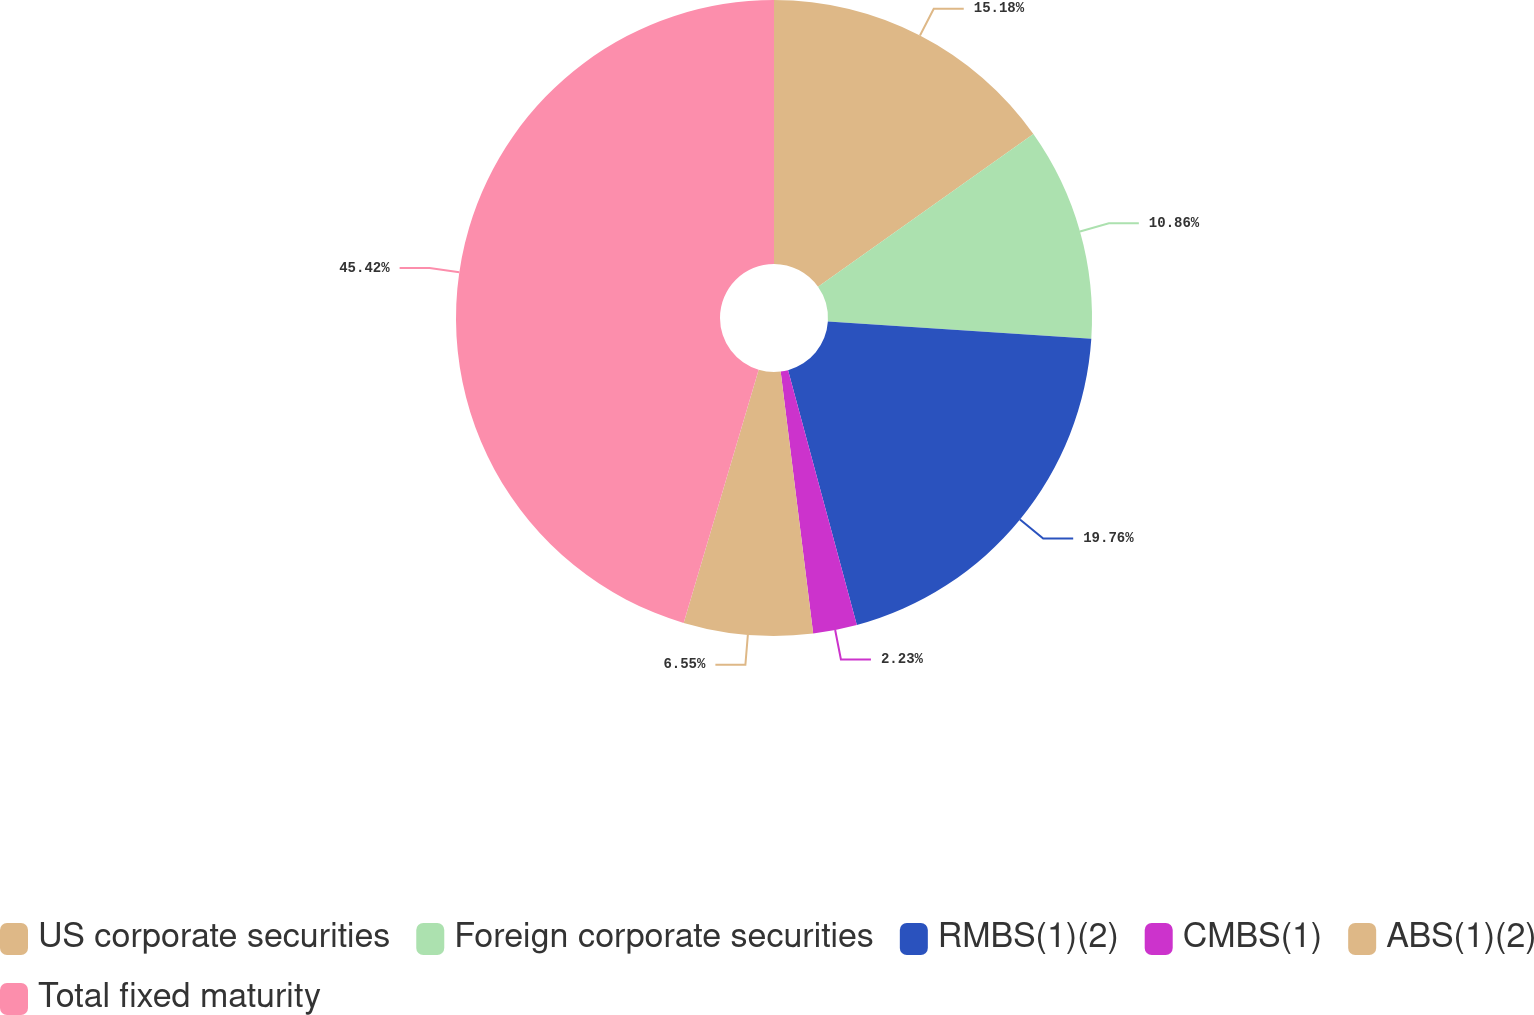Convert chart. <chart><loc_0><loc_0><loc_500><loc_500><pie_chart><fcel>US corporate securities<fcel>Foreign corporate securities<fcel>RMBS(1)(2)<fcel>CMBS(1)<fcel>ABS(1)(2)<fcel>Total fixed maturity<nl><fcel>15.18%<fcel>10.86%<fcel>19.76%<fcel>2.23%<fcel>6.55%<fcel>45.41%<nl></chart> 